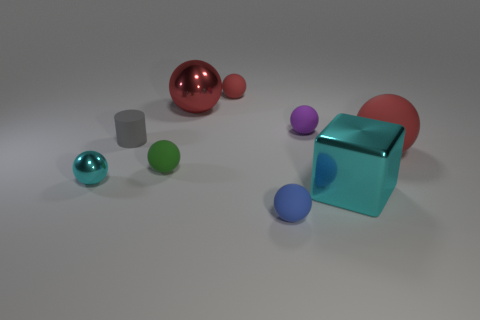What is the shape of the metal object that is in front of the purple object and to the right of the green rubber thing?
Give a very brief answer. Cube. There is a red matte thing that is to the left of the blue rubber ball that is in front of the tiny gray cylinder; what shape is it?
Your response must be concise. Sphere. Is the green matte object the same shape as the big red metallic object?
Provide a short and direct response. Yes. What is the material of the cube that is the same color as the tiny shiny object?
Ensure brevity in your answer.  Metal. Does the metallic cube have the same color as the small shiny object?
Provide a succinct answer. Yes. How many red matte spheres are behind the red rubber sphere behind the large ball that is behind the matte cylinder?
Your response must be concise. 0. What shape is the red thing that is made of the same material as the small cyan object?
Provide a short and direct response. Sphere. What material is the big sphere left of the matte ball in front of the cyan shiny object left of the big block made of?
Keep it short and to the point. Metal. What number of objects are small rubber things on the right side of the tiny red object or red metallic things?
Offer a very short reply. 3. How many other things are the same shape as the small green rubber thing?
Your answer should be compact. 6. 